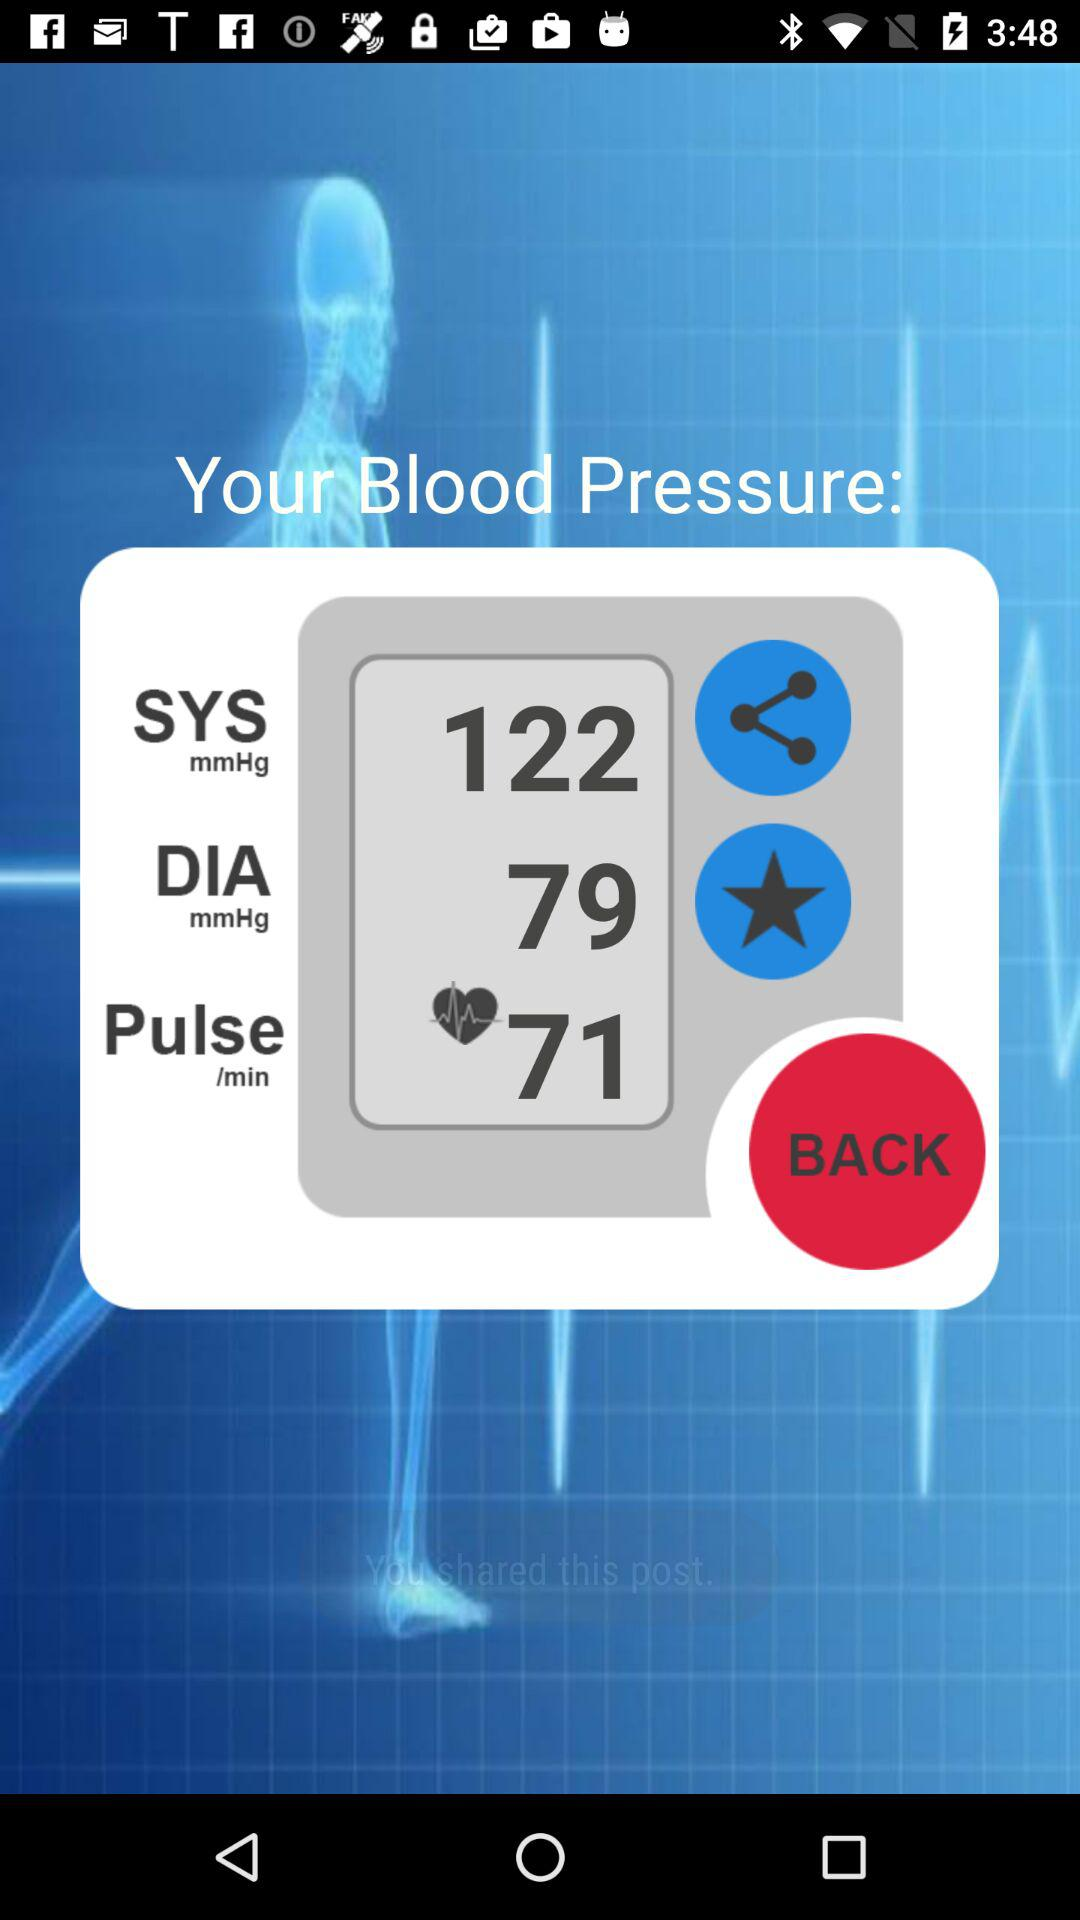What is the pulse rate? The pulse rate is 71. 